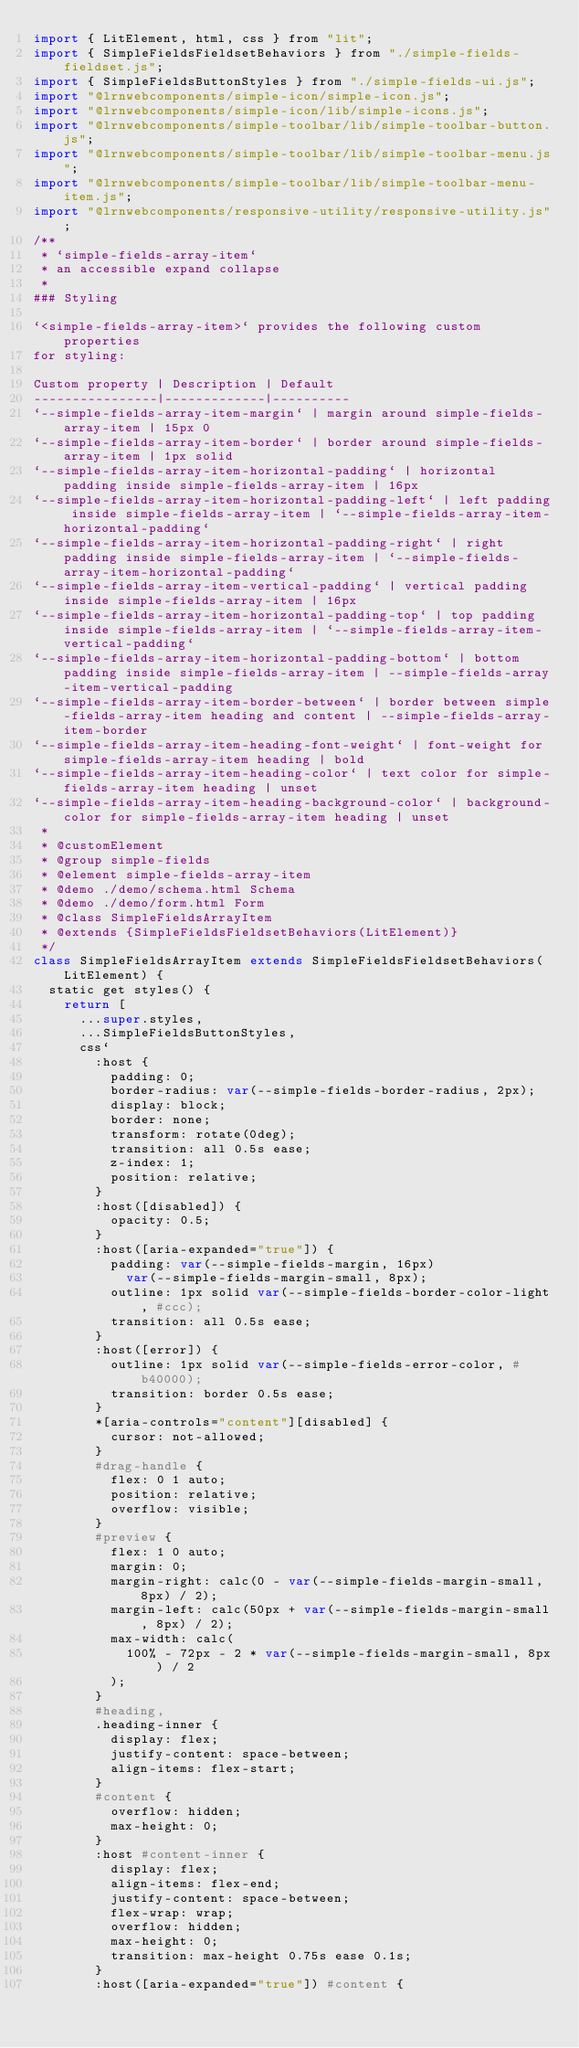Convert code to text. <code><loc_0><loc_0><loc_500><loc_500><_JavaScript_>import { LitElement, html, css } from "lit";
import { SimpleFieldsFieldsetBehaviors } from "./simple-fields-fieldset.js";
import { SimpleFieldsButtonStyles } from "./simple-fields-ui.js";
import "@lrnwebcomponents/simple-icon/simple-icon.js";
import "@lrnwebcomponents/simple-icon/lib/simple-icons.js";
import "@lrnwebcomponents/simple-toolbar/lib/simple-toolbar-button.js";
import "@lrnwebcomponents/simple-toolbar/lib/simple-toolbar-menu.js";
import "@lrnwebcomponents/simple-toolbar/lib/simple-toolbar-menu-item.js";
import "@lrnwebcomponents/responsive-utility/responsive-utility.js";
/**
 * `simple-fields-array-item`
 * an accessible expand collapse
 * 
### Styling

`<simple-fields-array-item>` provides the following custom properties
for styling:

Custom property | Description | Default
----------------|-------------|----------
`--simple-fields-array-item-margin` | margin around simple-fields-array-item | 15px 0
`--simple-fields-array-item-border` | border around simple-fields-array-item | 1px solid
`--simple-fields-array-item-horizontal-padding` | horizontal padding inside simple-fields-array-item | 16px
`--simple-fields-array-item-horizontal-padding-left` | left padding inside simple-fields-array-item | `--simple-fields-array-item-horizontal-padding`
`--simple-fields-array-item-horizontal-padding-right` | right padding inside simple-fields-array-item | `--simple-fields-array-item-horizontal-padding`
`--simple-fields-array-item-vertical-padding` | vertical padding inside simple-fields-array-item | 16px
`--simple-fields-array-item-horizontal-padding-top` | top padding inside simple-fields-array-item | `--simple-fields-array-item-vertical-padding`
`--simple-fields-array-item-horizontal-padding-bottom` | bottom padding inside simple-fields-array-item | --simple-fields-array-item-vertical-padding
`--simple-fields-array-item-border-between` | border between simple-fields-array-item heading and content | --simple-fields-array-item-border
`--simple-fields-array-item-heading-font-weight` | font-weight for simple-fields-array-item heading | bold
`--simple-fields-array-item-heading-color` | text color for simple-fields-array-item heading | unset
`--simple-fields-array-item-heading-background-color` | background-color for simple-fields-array-item heading | unset
 *
 * @customElement
 * @group simple-fields
 * @element simple-fields-array-item
 * @demo ./demo/schema.html Schema
 * @demo ./demo/form.html Form
 * @class SimpleFieldsArrayItem
 * @extends {SimpleFieldsFieldsetBehaviors(LitElement)}
 */
class SimpleFieldsArrayItem extends SimpleFieldsFieldsetBehaviors(LitElement) {
  static get styles() {
    return [
      ...super.styles,
      ...SimpleFieldsButtonStyles,
      css`
        :host {
          padding: 0;
          border-radius: var(--simple-fields-border-radius, 2px);
          display: block;
          border: none;
          transform: rotate(0deg);
          transition: all 0.5s ease;
          z-index: 1;
          position: relative;
        }
        :host([disabled]) {
          opacity: 0.5;
        }
        :host([aria-expanded="true"]) {
          padding: var(--simple-fields-margin, 16px)
            var(--simple-fields-margin-small, 8px);
          outline: 1px solid var(--simple-fields-border-color-light, #ccc);
          transition: all 0.5s ease;
        }
        :host([error]) {
          outline: 1px solid var(--simple-fields-error-color, #b40000);
          transition: border 0.5s ease;
        }
        *[aria-controls="content"][disabled] {
          cursor: not-allowed;
        }
        #drag-handle {
          flex: 0 1 auto;
          position: relative;
          overflow: visible;
        }
        #preview {
          flex: 1 0 auto;
          margin: 0;
          margin-right: calc(0 - var(--simple-fields-margin-small, 8px) / 2);
          margin-left: calc(50px + var(--simple-fields-margin-small, 8px) / 2);
          max-width: calc(
            100% - 72px - 2 * var(--simple-fields-margin-small, 8px) / 2
          );
        }
        #heading,
        .heading-inner {
          display: flex;
          justify-content: space-between;
          align-items: flex-start;
        }
        #content {
          overflow: hidden;
          max-height: 0;
        }
        :host #content-inner {
          display: flex;
          align-items: flex-end;
          justify-content: space-between;
          flex-wrap: wrap;
          overflow: hidden;
          max-height: 0;
          transition: max-height 0.75s ease 0.1s;
        }
        :host([aria-expanded="true"]) #content {</code> 